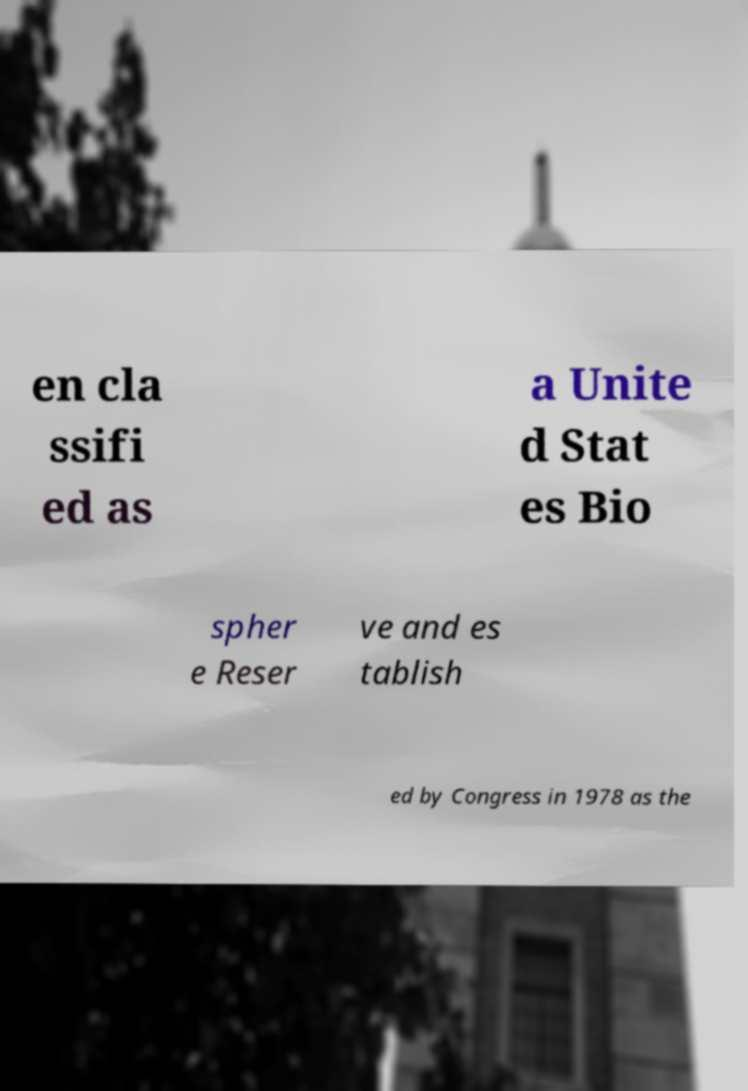Can you accurately transcribe the text from the provided image for me? en cla ssifi ed as a Unite d Stat es Bio spher e Reser ve and es tablish ed by Congress in 1978 as the 